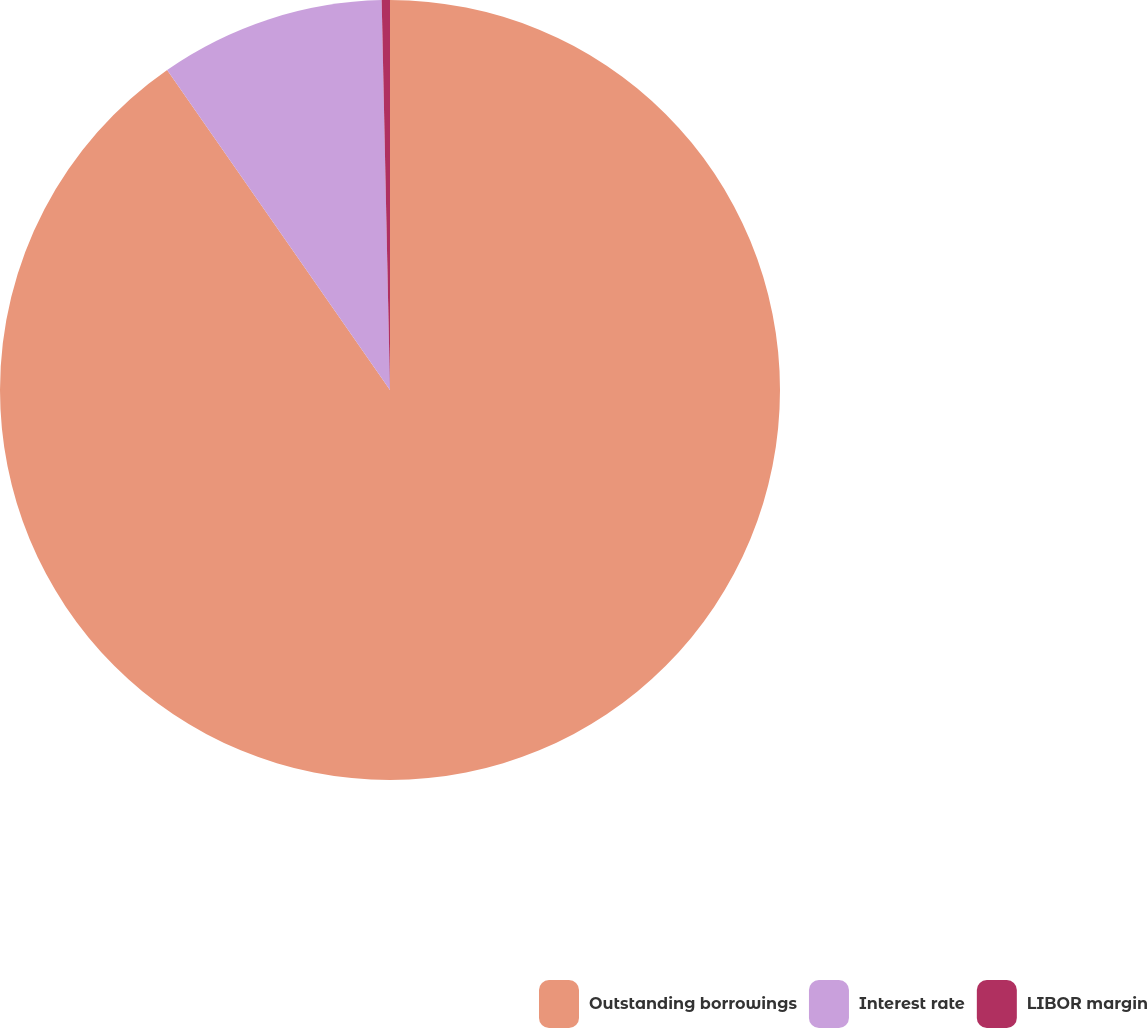Convert chart. <chart><loc_0><loc_0><loc_500><loc_500><pie_chart><fcel>Outstanding borrowings<fcel>Interest rate<fcel>LIBOR margin<nl><fcel>90.31%<fcel>9.34%<fcel>0.34%<nl></chart> 